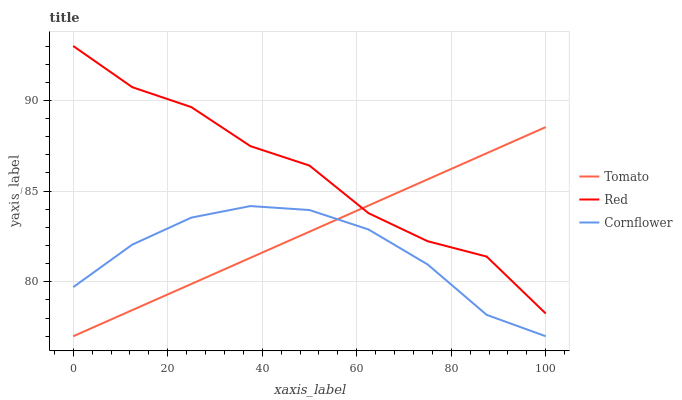Does Cornflower have the minimum area under the curve?
Answer yes or no. Yes. Does Red have the maximum area under the curve?
Answer yes or no. Yes. Does Red have the minimum area under the curve?
Answer yes or no. No. Does Cornflower have the maximum area under the curve?
Answer yes or no. No. Is Tomato the smoothest?
Answer yes or no. Yes. Is Red the roughest?
Answer yes or no. Yes. Is Cornflower the smoothest?
Answer yes or no. No. Is Cornflower the roughest?
Answer yes or no. No. Does Red have the lowest value?
Answer yes or no. No. Does Red have the highest value?
Answer yes or no. Yes. Does Cornflower have the highest value?
Answer yes or no. No. Is Cornflower less than Red?
Answer yes or no. Yes. Is Red greater than Cornflower?
Answer yes or no. Yes. Does Tomato intersect Cornflower?
Answer yes or no. Yes. Is Tomato less than Cornflower?
Answer yes or no. No. Is Tomato greater than Cornflower?
Answer yes or no. No. Does Cornflower intersect Red?
Answer yes or no. No. 